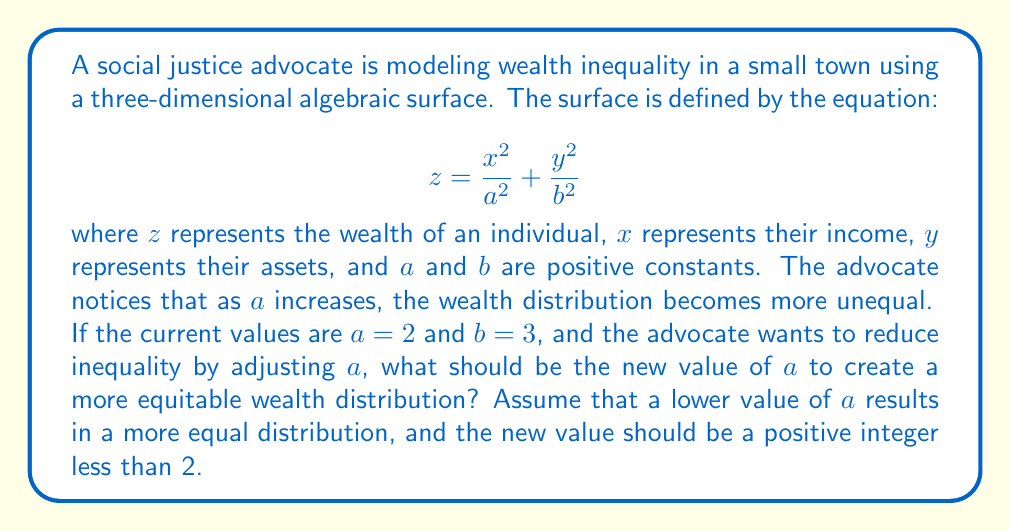Show me your answer to this math problem. To solve this problem, let's analyze the given equation and the effect of changing $a$:

1) The equation of the surface is:
   $$ z = \frac{x^2}{a^2} + \frac{y^2}{b^2} $$

2) We're told that as $a$ increases, wealth inequality increases. This means that to reduce inequality, we need to decrease $a$.

3) Currently, $a=2$ and $b=3$.

4) We need to choose a new value for $a$ that is:
   - A positive integer
   - Less than 2
   - Will reduce inequality

5) The only positive integer less than 2 is 1.

6) Let's compare the surfaces with $a=2$ and $a=1$:

   For $a=2$: $$ z = \frac{x^2}{4} + \frac{y^2}{9} $$
   For $a=1$: $$ z = x^2 + \frac{y^2}{9} $$

7) When $a=1$, the coefficient of $x^2$ is larger, which means the surface will be steeper in the $x$ direction. This results in a more compressed distribution of wealth, indicating less inequality.

Therefore, to create a more equitable wealth distribution, the advocate should set the new value of $a$ to 1.
Answer: $a = 1$ 